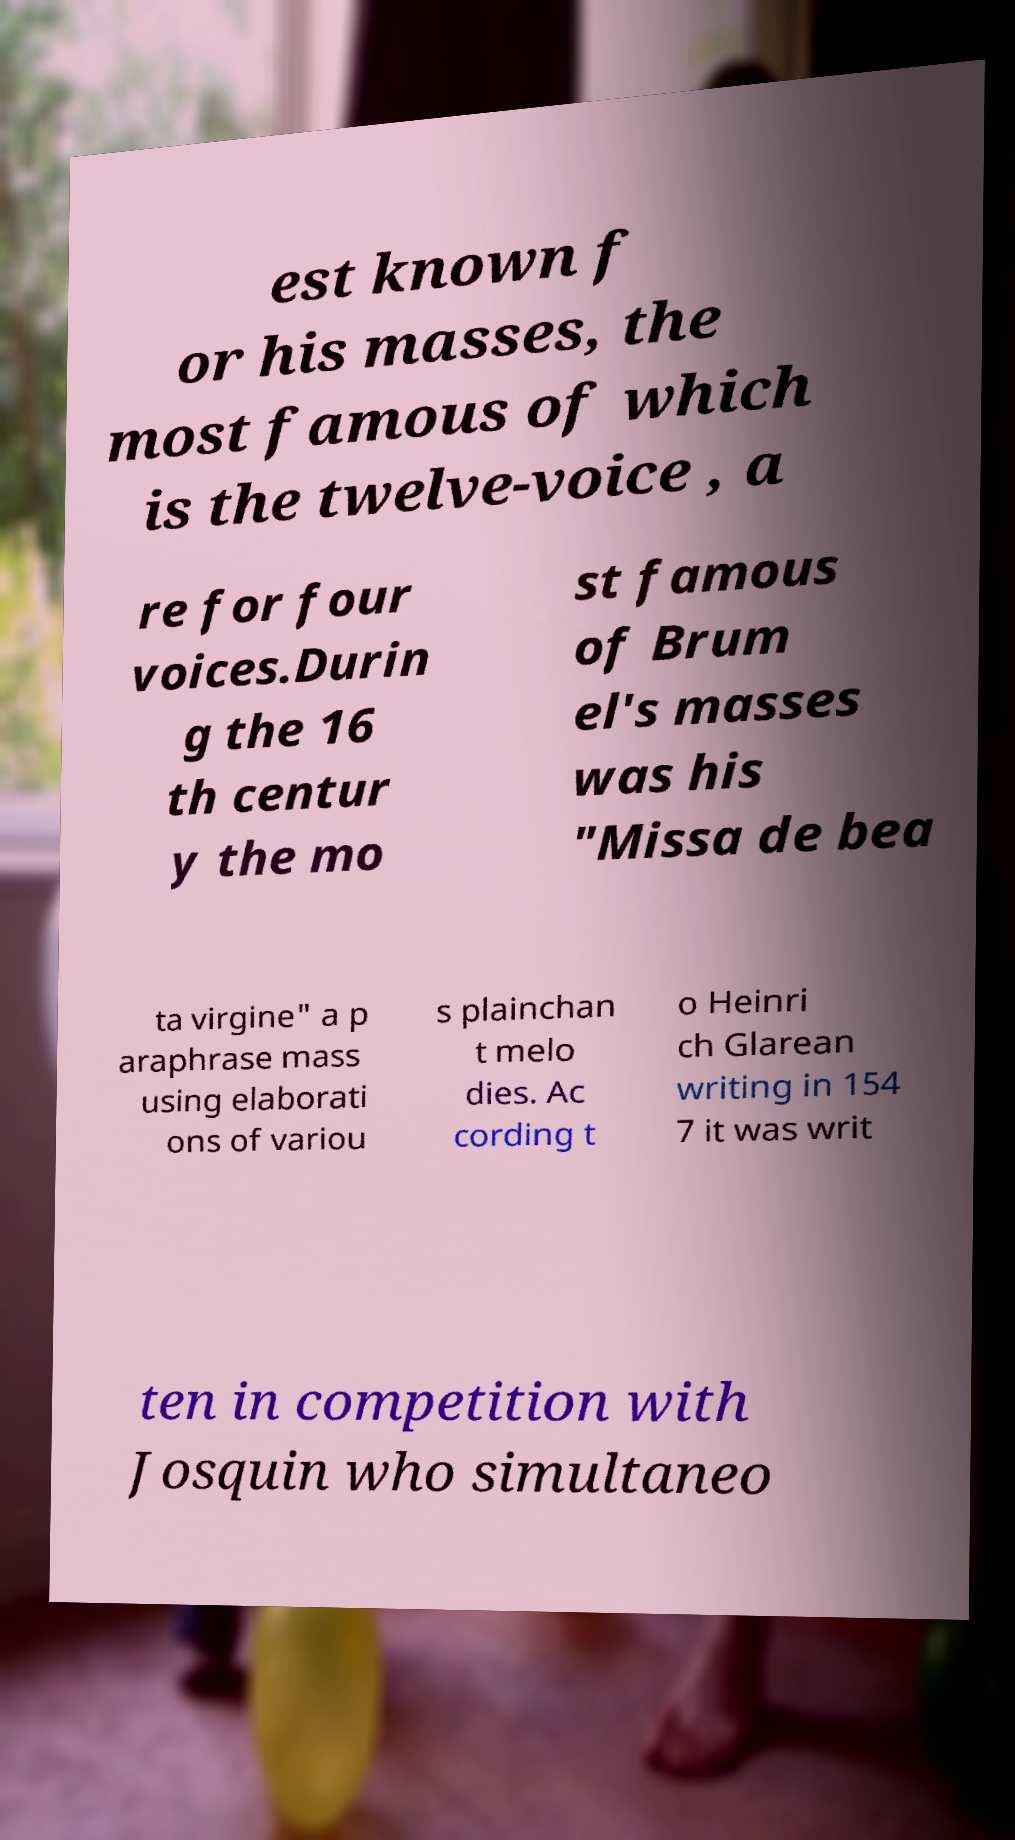Please read and relay the text visible in this image. What does it say? est known f or his masses, the most famous of which is the twelve-voice , a re for four voices.Durin g the 16 th centur y the mo st famous of Brum el's masses was his "Missa de bea ta virgine" a p araphrase mass using elaborati ons of variou s plainchan t melo dies. Ac cording t o Heinri ch Glarean writing in 154 7 it was writ ten in competition with Josquin who simultaneo 